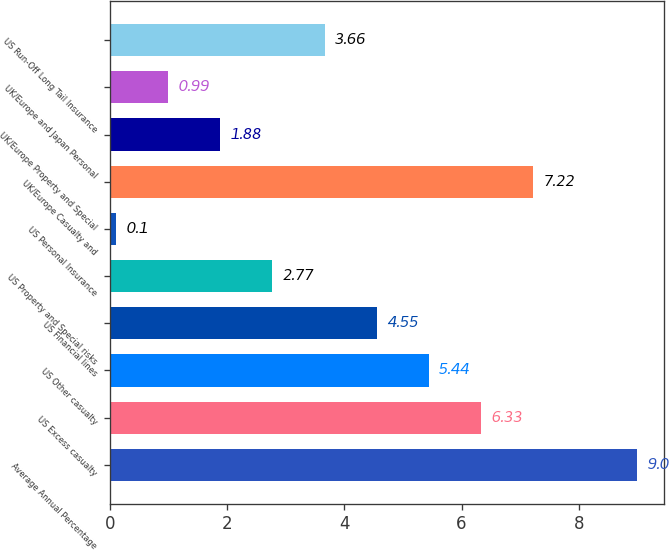<chart> <loc_0><loc_0><loc_500><loc_500><bar_chart><fcel>Average Annual Percentage<fcel>US Excess casualty<fcel>US Other casualty<fcel>US Financial lines<fcel>US Property and Special risks<fcel>US Personal Insurance<fcel>UK/Europe Casualty and<fcel>UK/Europe Property and Special<fcel>UK/Europe and Japan Personal<fcel>US Run-Off Long Tail Insurance<nl><fcel>9<fcel>6.33<fcel>5.44<fcel>4.55<fcel>2.77<fcel>0.1<fcel>7.22<fcel>1.88<fcel>0.99<fcel>3.66<nl></chart> 